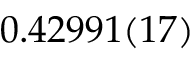<formula> <loc_0><loc_0><loc_500><loc_500>0 . 4 2 9 9 1 ( 1 7 )</formula> 